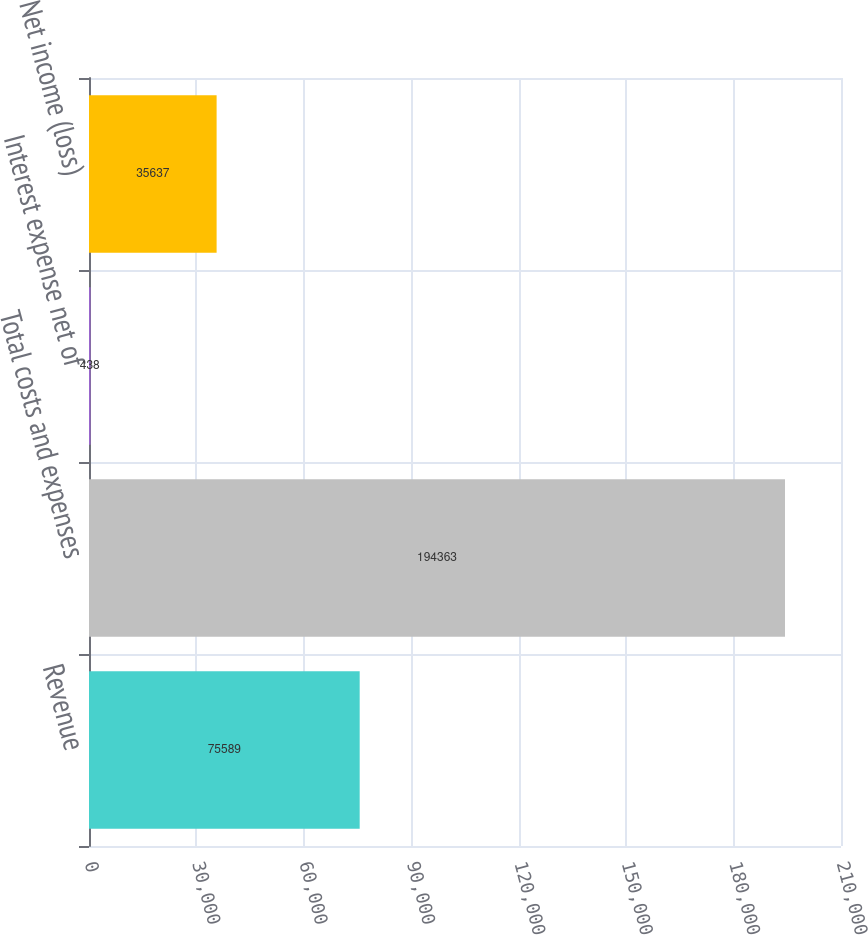<chart> <loc_0><loc_0><loc_500><loc_500><bar_chart><fcel>Revenue<fcel>Total costs and expenses<fcel>Interest expense net of<fcel>Net income (loss)<nl><fcel>75589<fcel>194363<fcel>438<fcel>35637<nl></chart> 